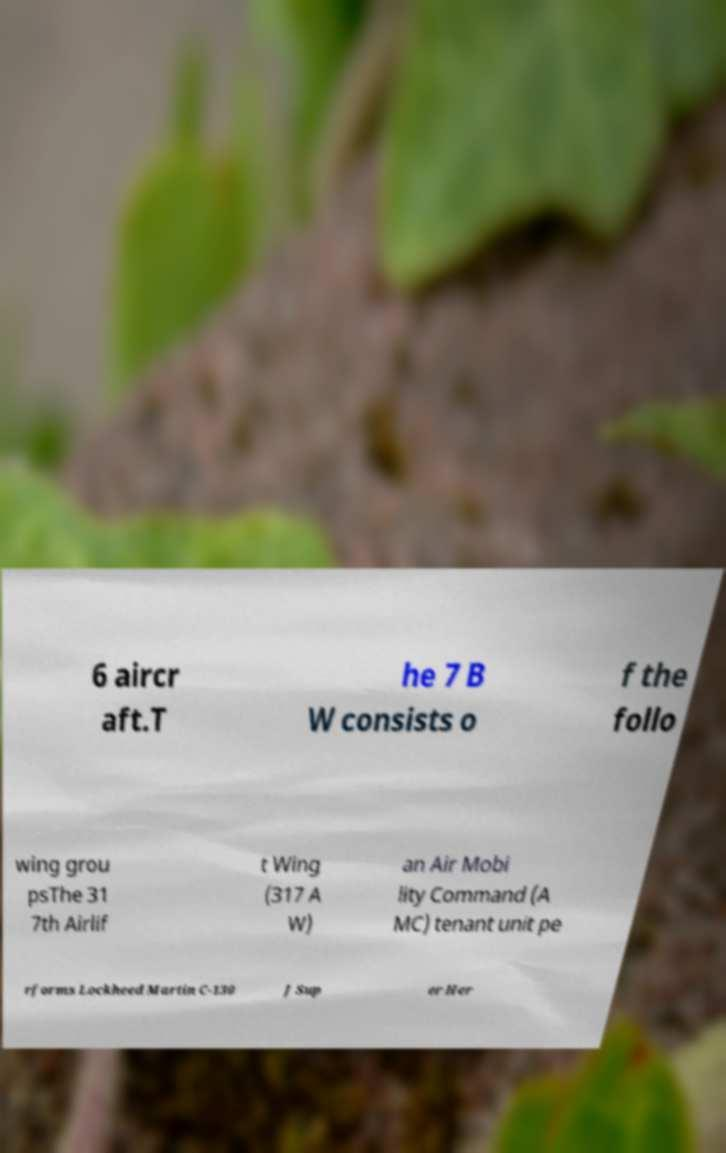Could you extract and type out the text from this image? 6 aircr aft.T he 7 B W consists o f the follo wing grou psThe 31 7th Airlif t Wing (317 A W) an Air Mobi lity Command (A MC) tenant unit pe rforms Lockheed Martin C-130 J Sup er Her 